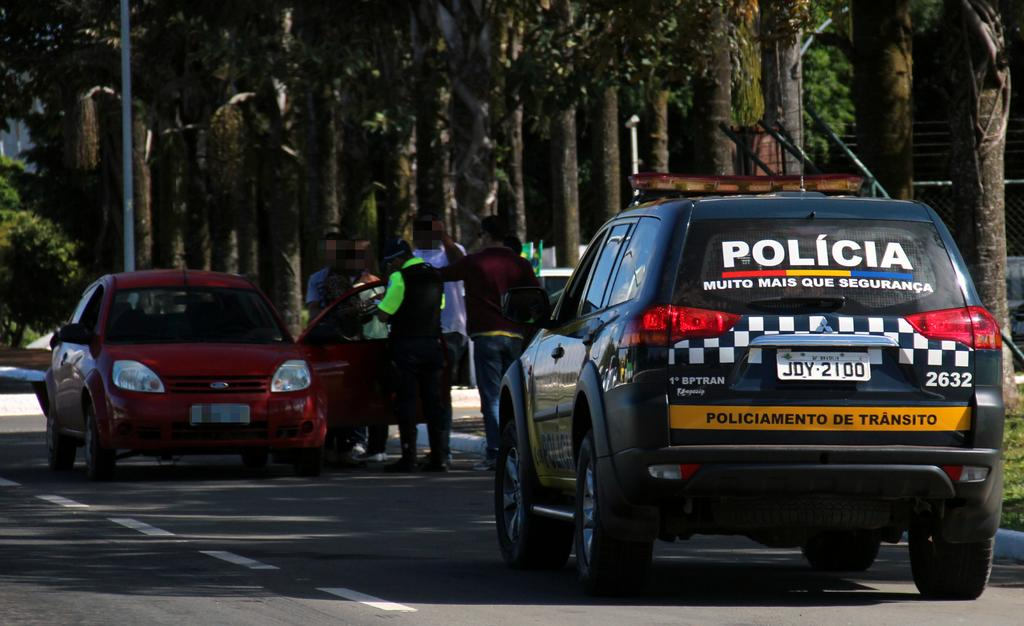What is located at the bottom of the image? There is a road at the bottom of the image. What can be seen on the road? Cars are present on the road. What is happening in the center of the image? There are people standing in the center of the image. What is visible in the background of the image? There are trees and a pole in the background of the image. How many chairs can be seen in the image? There are no chairs present in the image. Is there a plane visible in the image? No, there is no plane visible in the image. 